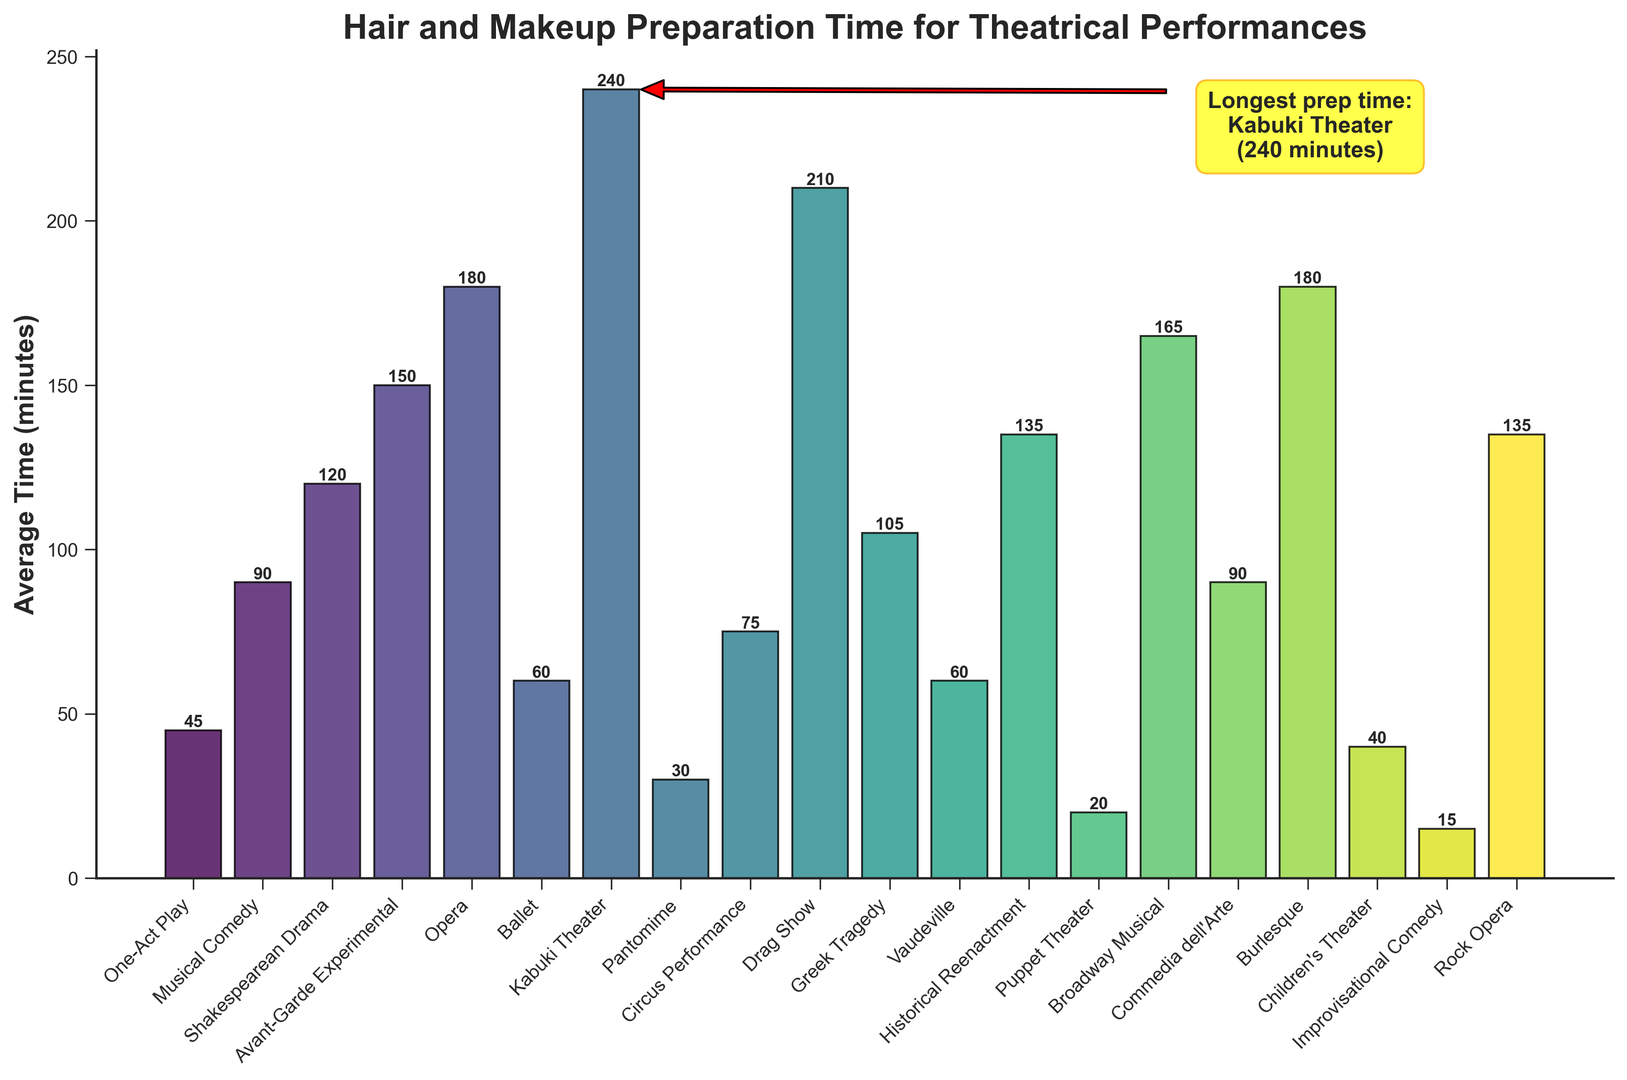Which performance type requires the longest preparation time? Find the tallest bar and check the annotation. The Kabuki Theater requires 240 minutes of preparation time, which is the longest.
Answer: Kabuki Theater Which performance type spends the least time on hair and makeup? Look for the shortest bar in the figure. The shortest bar corresponds to Improvisational Comedy, which spends 15 minutes.
Answer: Improvisational Comedy How much more time is spent on Broadway Musical compared to Children's Theater? Look at the heights of the Broadway Musical and Children's Theater bars. Broadway Musical is 165 minutes and Children's Theater is 40 minutes. Subtracting 40 from 165 gives 125 minutes.
Answer: 125 minutes Which types of performances spend exactly 90 minutes on preparation? Identify the bar heights, noting those at 90 minutes. Both Musical Comedy and Commedia dell'Arte spend 90 minutes on preparation.
Answer: Musical Comedy and Commedia dell'Arte What's the combined preparation time for Ballet and Drag Show? Look at the bar heights for Ballet and Drag Show. Ballet is 60 minutes and Drag Show is 210 minutes. Adding them together gives 270 minutes.
Answer: 270 minutes Which has a higher preparation time, Opera or Historical Reenactment? Compare the bar heights for Opera and Historical Reenactment. Opera is 180 minutes and Historical Reenactment is 135 minutes. Since 180 is greater than 135, Opera has a higher preparation time.
Answer: Opera What is the visual attribute used to highlight the longest preparation time performance? Observe the unique characteristics of the annotation. The annotation shows a red arrow pointing to Kabuki Theater with a yellow box around the text.
Answer: Red arrow and yellow box How many performance types have a preparation time greater than 150 minutes? Count the bars that exceed the 150-minute mark. These bars correspond to Avant-Garde Experimental, Opera, Kabuki Theater, Drag Show, Burlesque, Broadway Musical, and Rock Opera, totaling 7 types.
Answer: 7 types What is the total preparation time for the three performances with the shortest times? Add the times of Improvisational Comedy (15 minutes), Puppet Theater (20 minutes), and Pantomime (30 minutes). 15 + 20 + 30 equals 65 minutes.
Answer: 65 minutes Which performance type has a preparation time exactly midway between the preparation times of Ballet and Circus Performance? Find the preparation times for Ballet (60 minutes) and Circus Performance (75 minutes), calculate the mid-point (60+75)/2 = 67.5 minutes. Greek Tragedy at 105 minutes and Burlesque at 180 minutes; none fall at 67.5 minutes exactly. Note the question can't be answered this way, so check the next nearest match (excluding narrow intervals) which isn't applicable.
Answer: None 